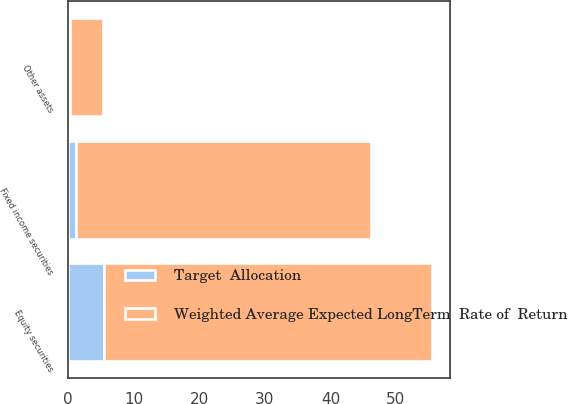Convert chart. <chart><loc_0><loc_0><loc_500><loc_500><stacked_bar_chart><ecel><fcel>Equity securities<fcel>Fixed income securities<fcel>Other assets<nl><fcel>Weighted Average Expected LongTerm  Rate of  Return<fcel>50<fcel>45<fcel>5<nl><fcel>Target  Allocation<fcel>5.5<fcel>1.2<fcel>0.3<nl></chart> 